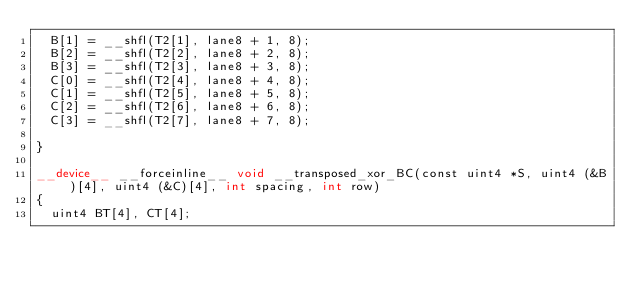Convert code to text. <code><loc_0><loc_0><loc_500><loc_500><_Cuda_>	B[1] = __shfl(T2[1], lane8 + 1, 8);
	B[2] = __shfl(T2[2], lane8 + 2, 8);
	B[3] = __shfl(T2[3], lane8 + 3, 8);
	C[0] = __shfl(T2[4], lane8 + 4, 8);
	C[1] = __shfl(T2[5], lane8 + 5, 8);
	C[2] = __shfl(T2[6], lane8 + 6, 8);
	C[3] = __shfl(T2[7], lane8 + 7, 8);

}

__device__ __forceinline__ void __transposed_xor_BC(const uint4 *S, uint4 (&B)[4], uint4 (&C)[4], int spacing, int row)
{
	uint4 BT[4], CT[4];</code> 